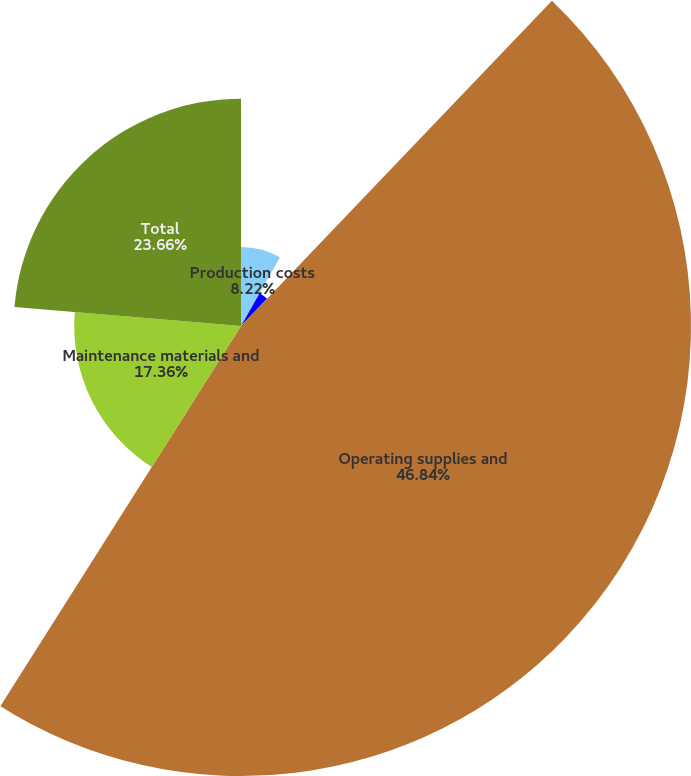Convert chart to OTSL. <chart><loc_0><loc_0><loc_500><loc_500><pie_chart><fcel>Production costs<fcel>Employee-related costs<fcel>Operating supplies and<fcel>Maintenance materials and<fcel>Total<nl><fcel>8.22%<fcel>3.92%<fcel>46.84%<fcel>17.36%<fcel>23.66%<nl></chart> 